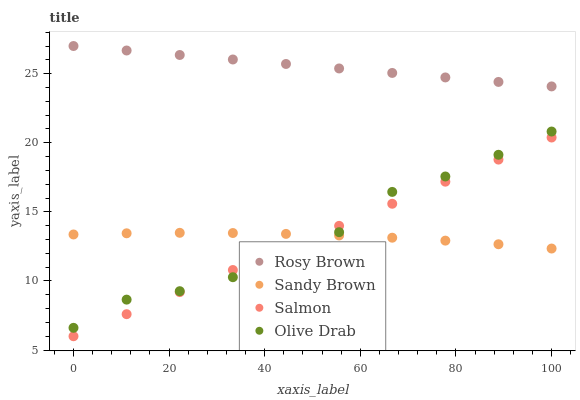Does Sandy Brown have the minimum area under the curve?
Answer yes or no. Yes. Does Rosy Brown have the maximum area under the curve?
Answer yes or no. Yes. Does Rosy Brown have the minimum area under the curve?
Answer yes or no. No. Does Sandy Brown have the maximum area under the curve?
Answer yes or no. No. Is Salmon the smoothest?
Answer yes or no. Yes. Is Olive Drab the roughest?
Answer yes or no. Yes. Is Rosy Brown the smoothest?
Answer yes or no. No. Is Rosy Brown the roughest?
Answer yes or no. No. Does Salmon have the lowest value?
Answer yes or no. Yes. Does Sandy Brown have the lowest value?
Answer yes or no. No. Does Rosy Brown have the highest value?
Answer yes or no. Yes. Does Sandy Brown have the highest value?
Answer yes or no. No. Is Sandy Brown less than Rosy Brown?
Answer yes or no. Yes. Is Rosy Brown greater than Olive Drab?
Answer yes or no. Yes. Does Salmon intersect Olive Drab?
Answer yes or no. Yes. Is Salmon less than Olive Drab?
Answer yes or no. No. Is Salmon greater than Olive Drab?
Answer yes or no. No. Does Sandy Brown intersect Rosy Brown?
Answer yes or no. No. 